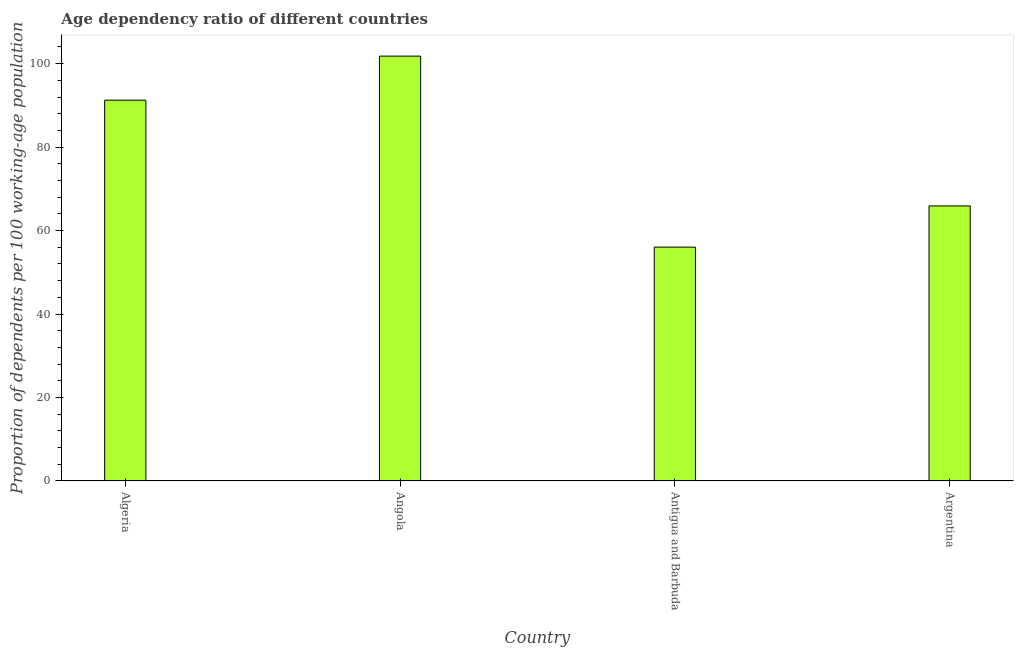What is the title of the graph?
Keep it short and to the point. Age dependency ratio of different countries. What is the label or title of the X-axis?
Your answer should be very brief. Country. What is the label or title of the Y-axis?
Provide a short and direct response. Proportion of dependents per 100 working-age population. What is the age dependency ratio in Algeria?
Your answer should be compact. 91.25. Across all countries, what is the maximum age dependency ratio?
Provide a succinct answer. 101.81. Across all countries, what is the minimum age dependency ratio?
Provide a succinct answer. 56.04. In which country was the age dependency ratio maximum?
Provide a short and direct response. Angola. In which country was the age dependency ratio minimum?
Offer a very short reply. Antigua and Barbuda. What is the sum of the age dependency ratio?
Ensure brevity in your answer.  315.02. What is the difference between the age dependency ratio in Angola and Argentina?
Ensure brevity in your answer.  35.89. What is the average age dependency ratio per country?
Provide a succinct answer. 78.76. What is the median age dependency ratio?
Your response must be concise. 78.59. What is the ratio of the age dependency ratio in Angola to that in Argentina?
Give a very brief answer. 1.54. What is the difference between the highest and the second highest age dependency ratio?
Keep it short and to the point. 10.56. Is the sum of the age dependency ratio in Algeria and Argentina greater than the maximum age dependency ratio across all countries?
Keep it short and to the point. Yes. What is the difference between the highest and the lowest age dependency ratio?
Your answer should be compact. 45.77. In how many countries, is the age dependency ratio greater than the average age dependency ratio taken over all countries?
Your answer should be very brief. 2. Are all the bars in the graph horizontal?
Provide a short and direct response. No. What is the difference between two consecutive major ticks on the Y-axis?
Ensure brevity in your answer.  20. What is the Proportion of dependents per 100 working-age population of Algeria?
Ensure brevity in your answer.  91.25. What is the Proportion of dependents per 100 working-age population in Angola?
Give a very brief answer. 101.81. What is the Proportion of dependents per 100 working-age population in Antigua and Barbuda?
Keep it short and to the point. 56.04. What is the Proportion of dependents per 100 working-age population of Argentina?
Your answer should be very brief. 65.92. What is the difference between the Proportion of dependents per 100 working-age population in Algeria and Angola?
Your response must be concise. -10.56. What is the difference between the Proportion of dependents per 100 working-age population in Algeria and Antigua and Barbuda?
Your answer should be very brief. 35.21. What is the difference between the Proportion of dependents per 100 working-age population in Algeria and Argentina?
Your response must be concise. 25.34. What is the difference between the Proportion of dependents per 100 working-age population in Angola and Antigua and Barbuda?
Make the answer very short. 45.77. What is the difference between the Proportion of dependents per 100 working-age population in Angola and Argentina?
Ensure brevity in your answer.  35.89. What is the difference between the Proportion of dependents per 100 working-age population in Antigua and Barbuda and Argentina?
Give a very brief answer. -9.88. What is the ratio of the Proportion of dependents per 100 working-age population in Algeria to that in Angola?
Provide a short and direct response. 0.9. What is the ratio of the Proportion of dependents per 100 working-age population in Algeria to that in Antigua and Barbuda?
Make the answer very short. 1.63. What is the ratio of the Proportion of dependents per 100 working-age population in Algeria to that in Argentina?
Ensure brevity in your answer.  1.38. What is the ratio of the Proportion of dependents per 100 working-age population in Angola to that in Antigua and Barbuda?
Give a very brief answer. 1.82. What is the ratio of the Proportion of dependents per 100 working-age population in Angola to that in Argentina?
Offer a very short reply. 1.54. 